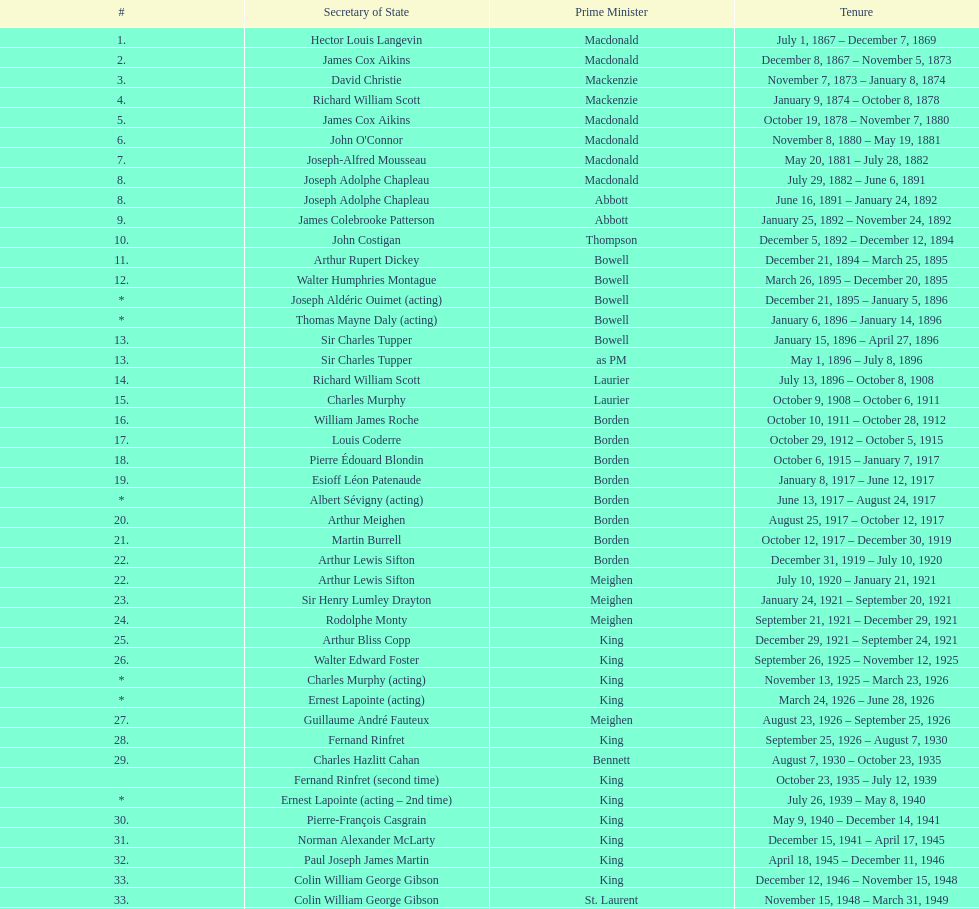Under prime minister macdonald, what was the number of secretaries of state? 6. 